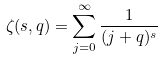Convert formula to latex. <formula><loc_0><loc_0><loc_500><loc_500>\zeta ( s , q ) = \sum _ { j = 0 } ^ { \infty } \frac { 1 } { ( j + q ) ^ { s } }</formula> 